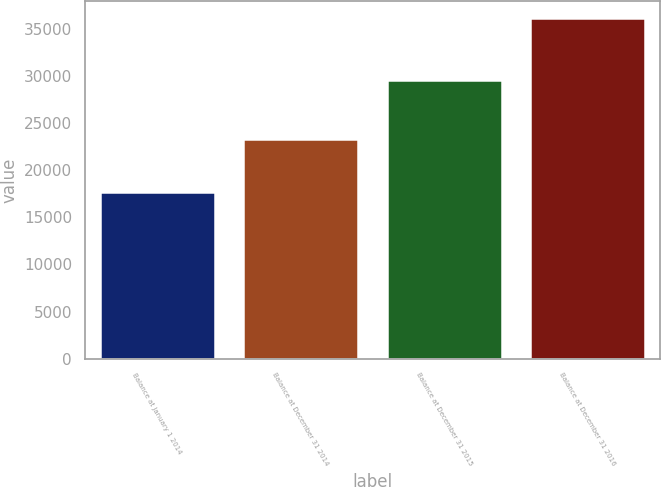Convert chart to OTSL. <chart><loc_0><loc_0><loc_500><loc_500><bar_chart><fcel>Balance at January 1 2014<fcel>Balance at December 31 2014<fcel>Balance at December 31 2015<fcel>Balance at December 31 2016<nl><fcel>17671<fcel>23298<fcel>29568<fcel>36097<nl></chart> 